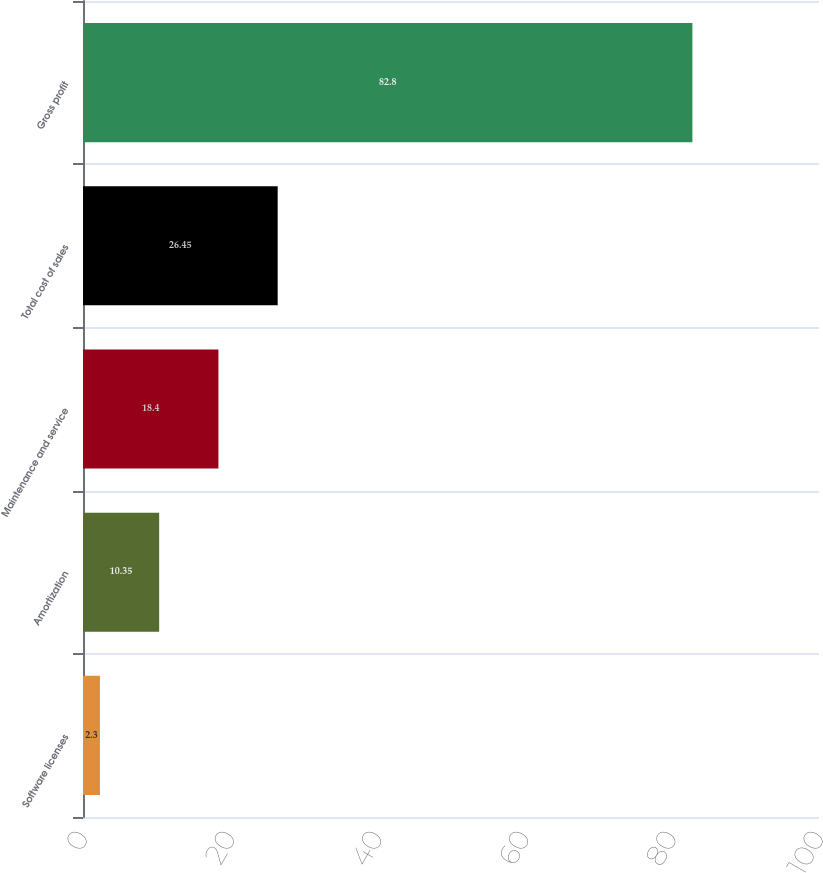Convert chart. <chart><loc_0><loc_0><loc_500><loc_500><bar_chart><fcel>Software licenses<fcel>Amortization<fcel>Maintenance and service<fcel>Total cost of sales<fcel>Gross profit<nl><fcel>2.3<fcel>10.35<fcel>18.4<fcel>26.45<fcel>82.8<nl></chart> 